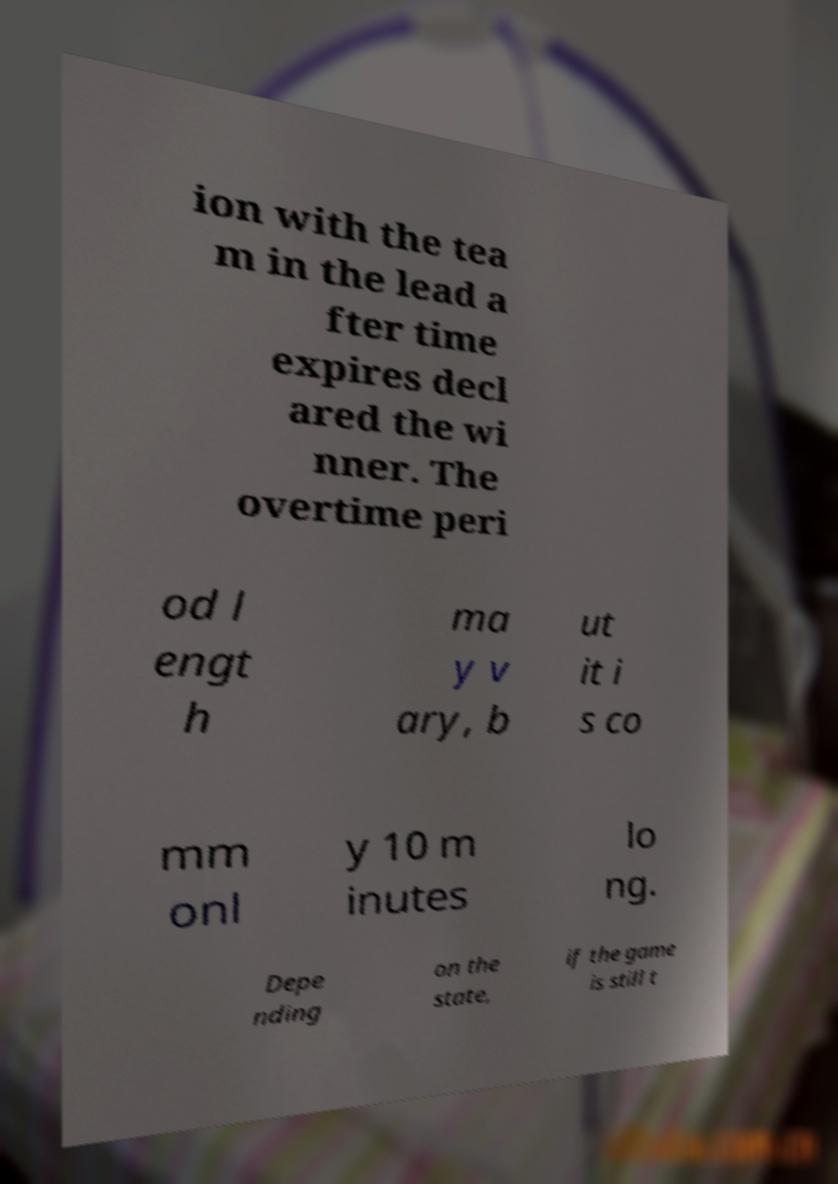I need the written content from this picture converted into text. Can you do that? ion with the tea m in the lead a fter time expires decl ared the wi nner. The overtime peri od l engt h ma y v ary, b ut it i s co mm onl y 10 m inutes lo ng. Depe nding on the state, if the game is still t 